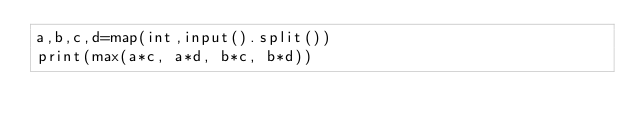<code> <loc_0><loc_0><loc_500><loc_500><_Python_>a,b,c,d=map(int,input().split())
print(max(a*c, a*d, b*c, b*d))</code> 